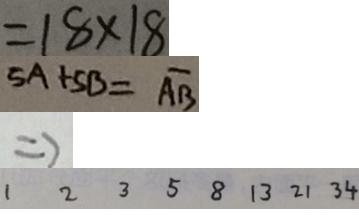Convert formula to latex. <formula><loc_0><loc_0><loc_500><loc_500>= 1 8 \times 1 8 
 5 A + 5 B = \overline { A B } 
 \Rightarrow 
 1 2 3 5 8 1 3 2 1 3 4</formula> 